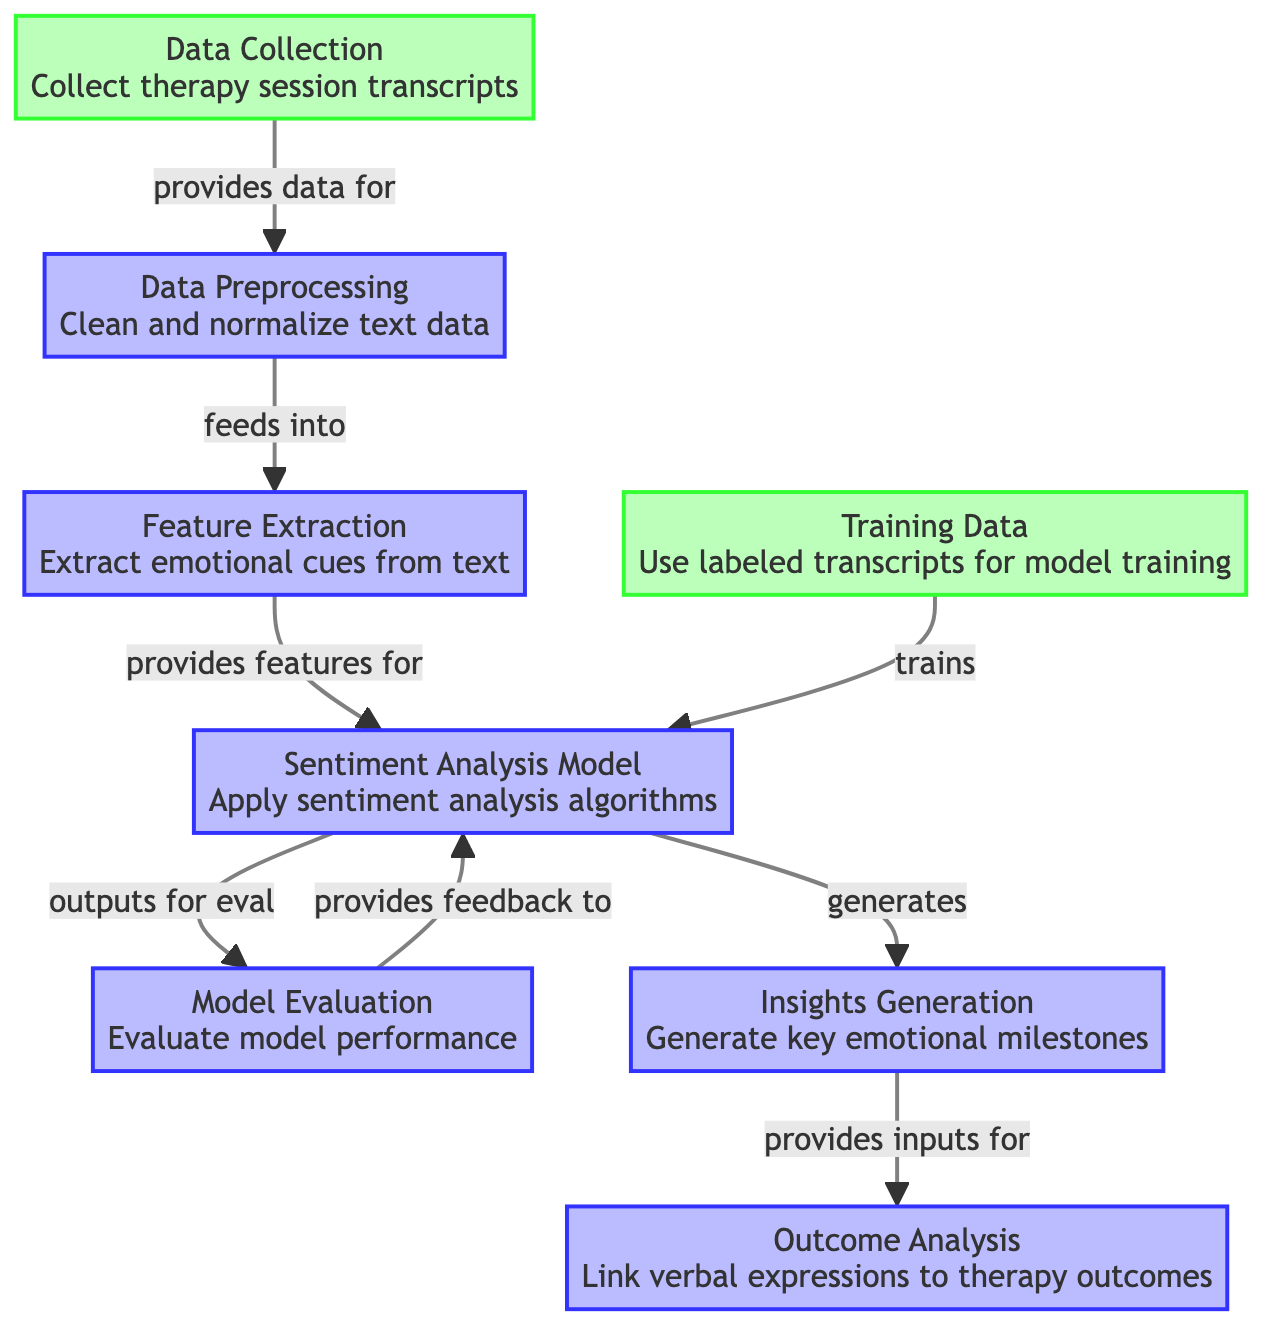What is the first step in the diagram? The first step in the diagram is labeled "Data Collection," which indicates that the initial phase involves gathering therapy session transcripts.
Answer: Data Collection How many main processing steps are in the diagram? The diagram shows six main processing steps: Data Preprocessing, Feature Extraction, Sentiment Analysis Model, Model Evaluation, Insights Generation, and Outcome Analysis, totaling six.
Answer: Six What does "Data Preprocessing" feed into? The "Data Preprocessing" node feeds into the "Feature Extraction" node, indicating that the cleaned and normalized text data is used as input for feature extraction.
Answer: Feature Extraction Which node generates key emotional milestones? The "Insights Generation" node is responsible for generating key emotional milestones based on the outputs from the Sentiment Analysis Model.
Answer: Insights Generation What is the relationship between "Sentiment Analysis Model" and "Model Evaluation"? The "Sentiment Analysis Model" outputs data that is evaluated in the "Model Evaluation" step, which assesses the performance of the model based on the outputs.
Answer: Outputs for eval How does "Training Data" interact with the "Sentiment Analysis Model"? "Training Data" is used to train the "Sentiment Analysis Model," meaning that labeled transcripts are employed to improve the model's performance on sentiment analysis tasks.
Answer: Trains Which process is linked to analysis of therapy outcomes? The "Outcome Analysis" node is linked to analyzing how verbal expressions are connected to therapy outcomes.
Answer: Outcome Analysis What type of model is applied in the diagram? The diagram utilizes a "Sentiment Analysis Model," indicating that the focus is on analyzing sentiments expressed in the therapy session transcripts.
Answer: Sentiment Analysis Model 